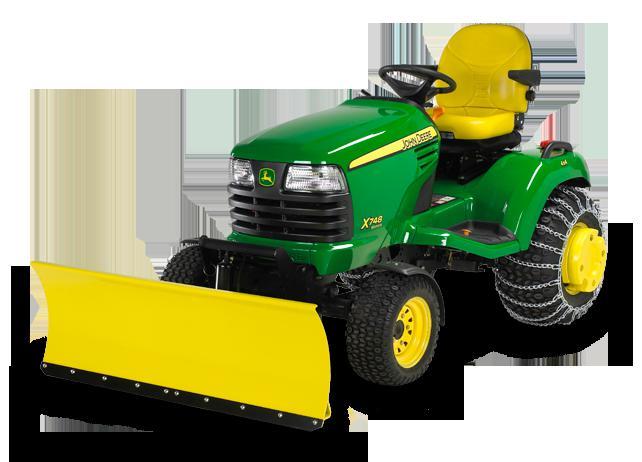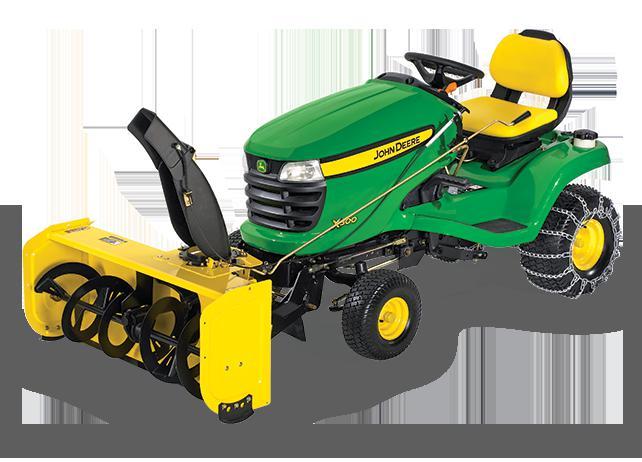The first image is the image on the left, the second image is the image on the right. Examine the images to the left and right. Is the description "An image shows a leftward-facing green tractor plowing snowy ground." accurate? Answer yes or no. No. The first image is the image on the left, the second image is the image on the right. Analyze the images presented: Is the assertion "In one image, a person wearing a coat and hat is plowing snow using a green tractor with yellow snow blade." valid? Answer yes or no. No. 